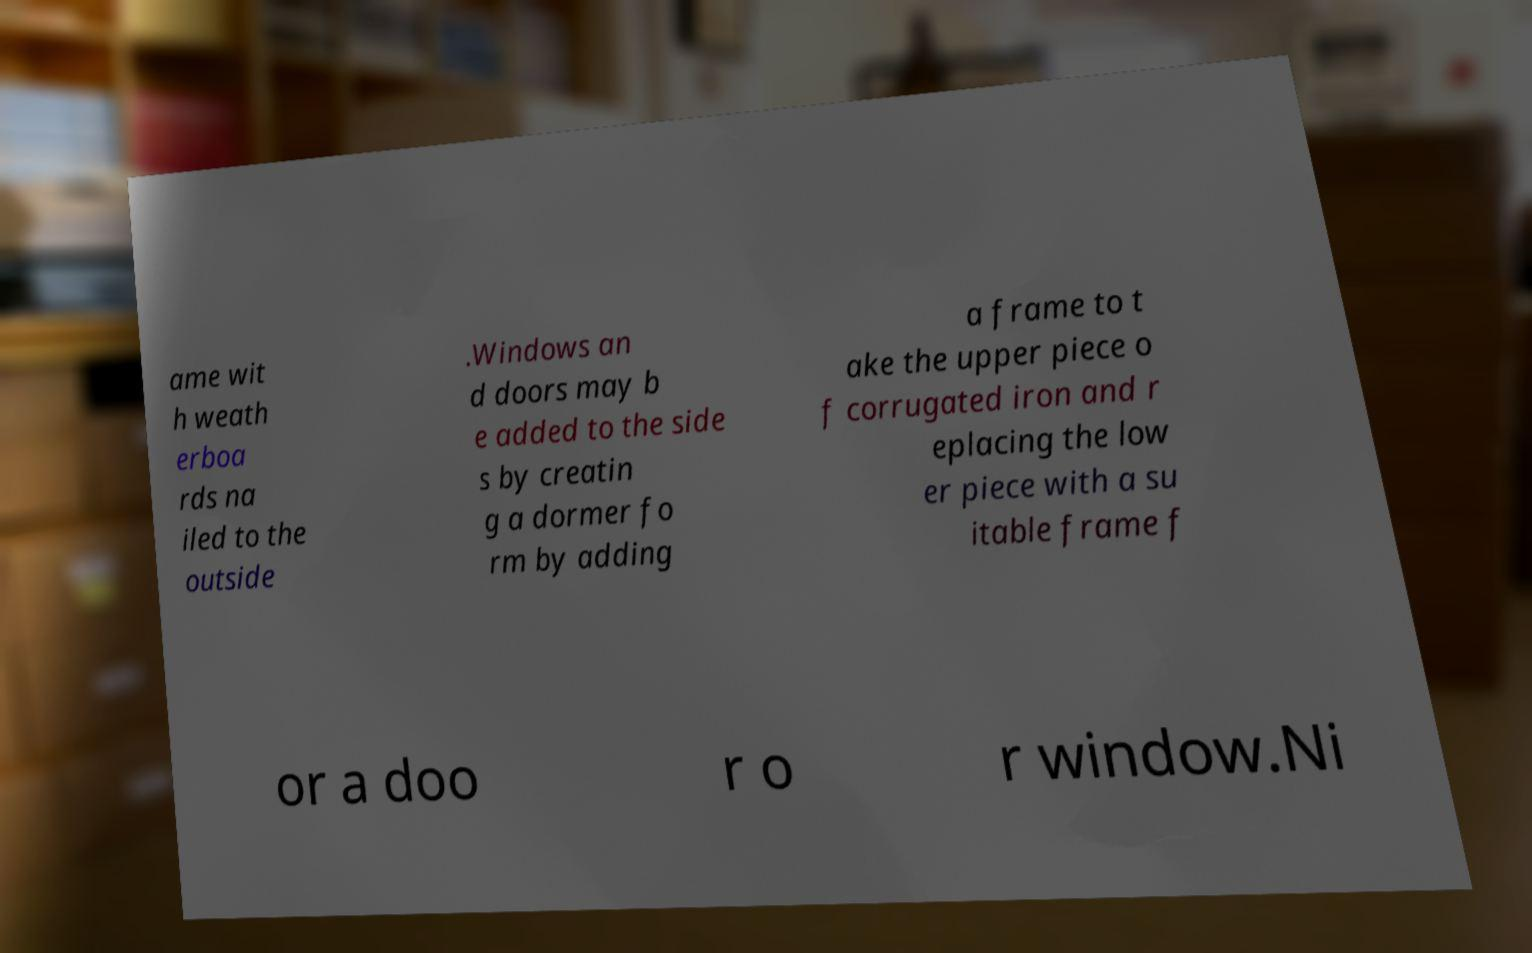Can you read and provide the text displayed in the image?This photo seems to have some interesting text. Can you extract and type it out for me? ame wit h weath erboa rds na iled to the outside .Windows an d doors may b e added to the side s by creatin g a dormer fo rm by adding a frame to t ake the upper piece o f corrugated iron and r eplacing the low er piece with a su itable frame f or a doo r o r window.Ni 